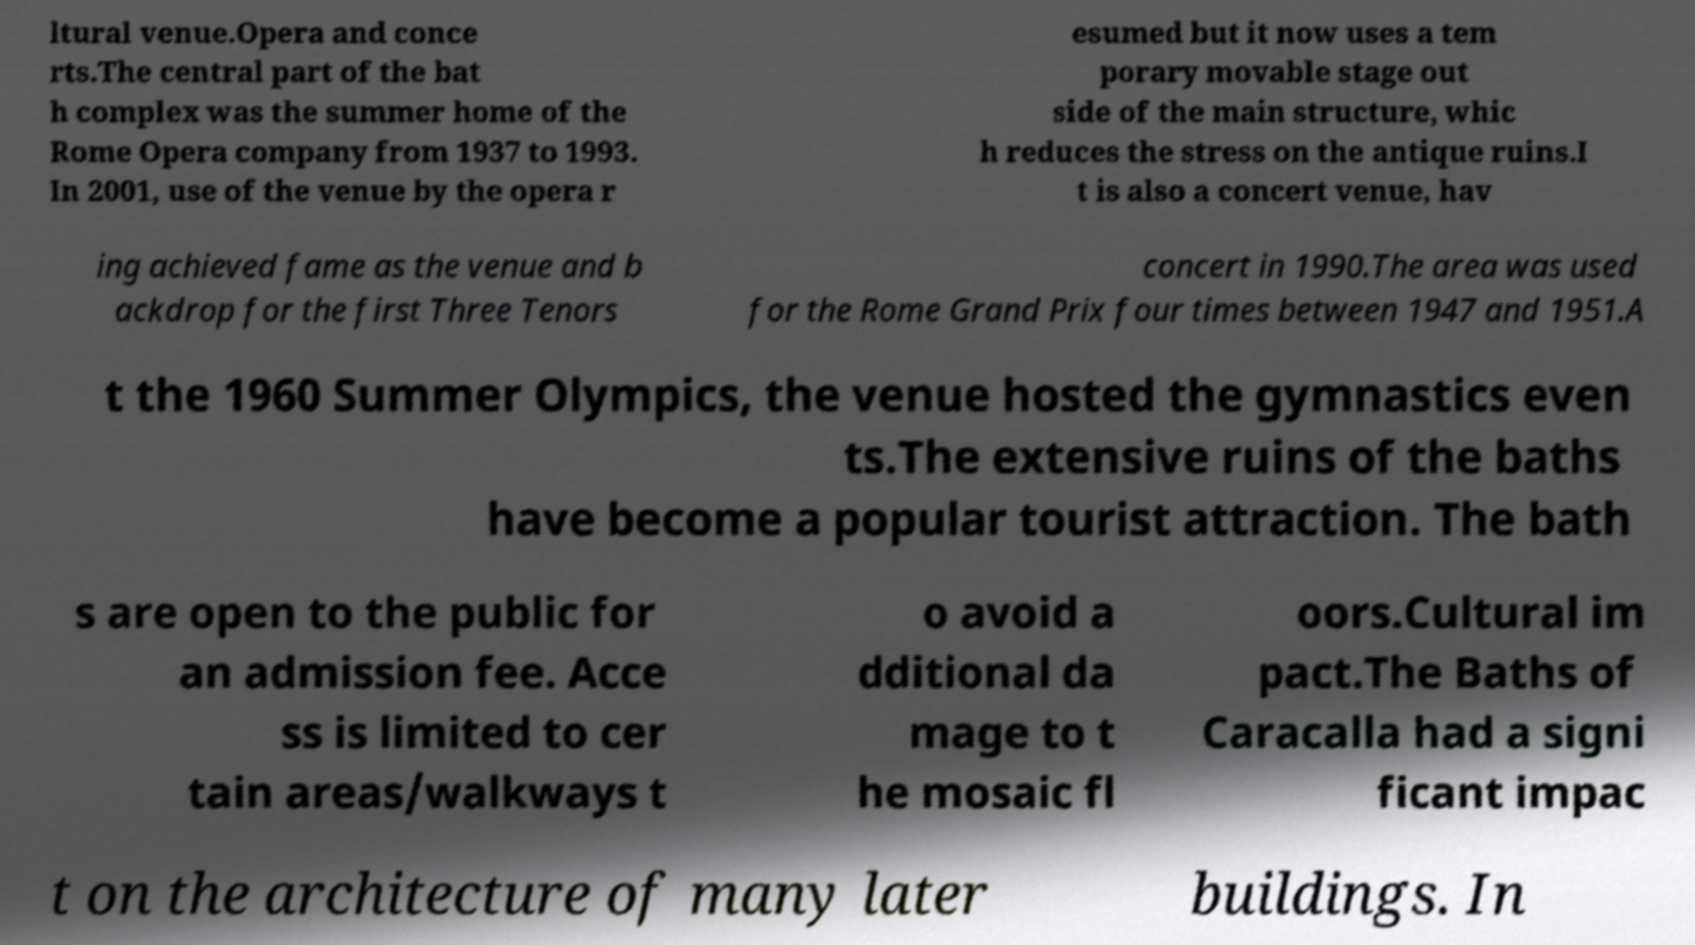I need the written content from this picture converted into text. Can you do that? ltural venue.Opera and conce rts.The central part of the bat h complex was the summer home of the Rome Opera company from 1937 to 1993. In 2001, use of the venue by the opera r esumed but it now uses a tem porary movable stage out side of the main structure, whic h reduces the stress on the antique ruins.I t is also a concert venue, hav ing achieved fame as the venue and b ackdrop for the first Three Tenors concert in 1990.The area was used for the Rome Grand Prix four times between 1947 and 1951.A t the 1960 Summer Olympics, the venue hosted the gymnastics even ts.The extensive ruins of the baths have become a popular tourist attraction. The bath s are open to the public for an admission fee. Acce ss is limited to cer tain areas/walkways t o avoid a dditional da mage to t he mosaic fl oors.Cultural im pact.The Baths of Caracalla had a signi ficant impac t on the architecture of many later buildings. In 